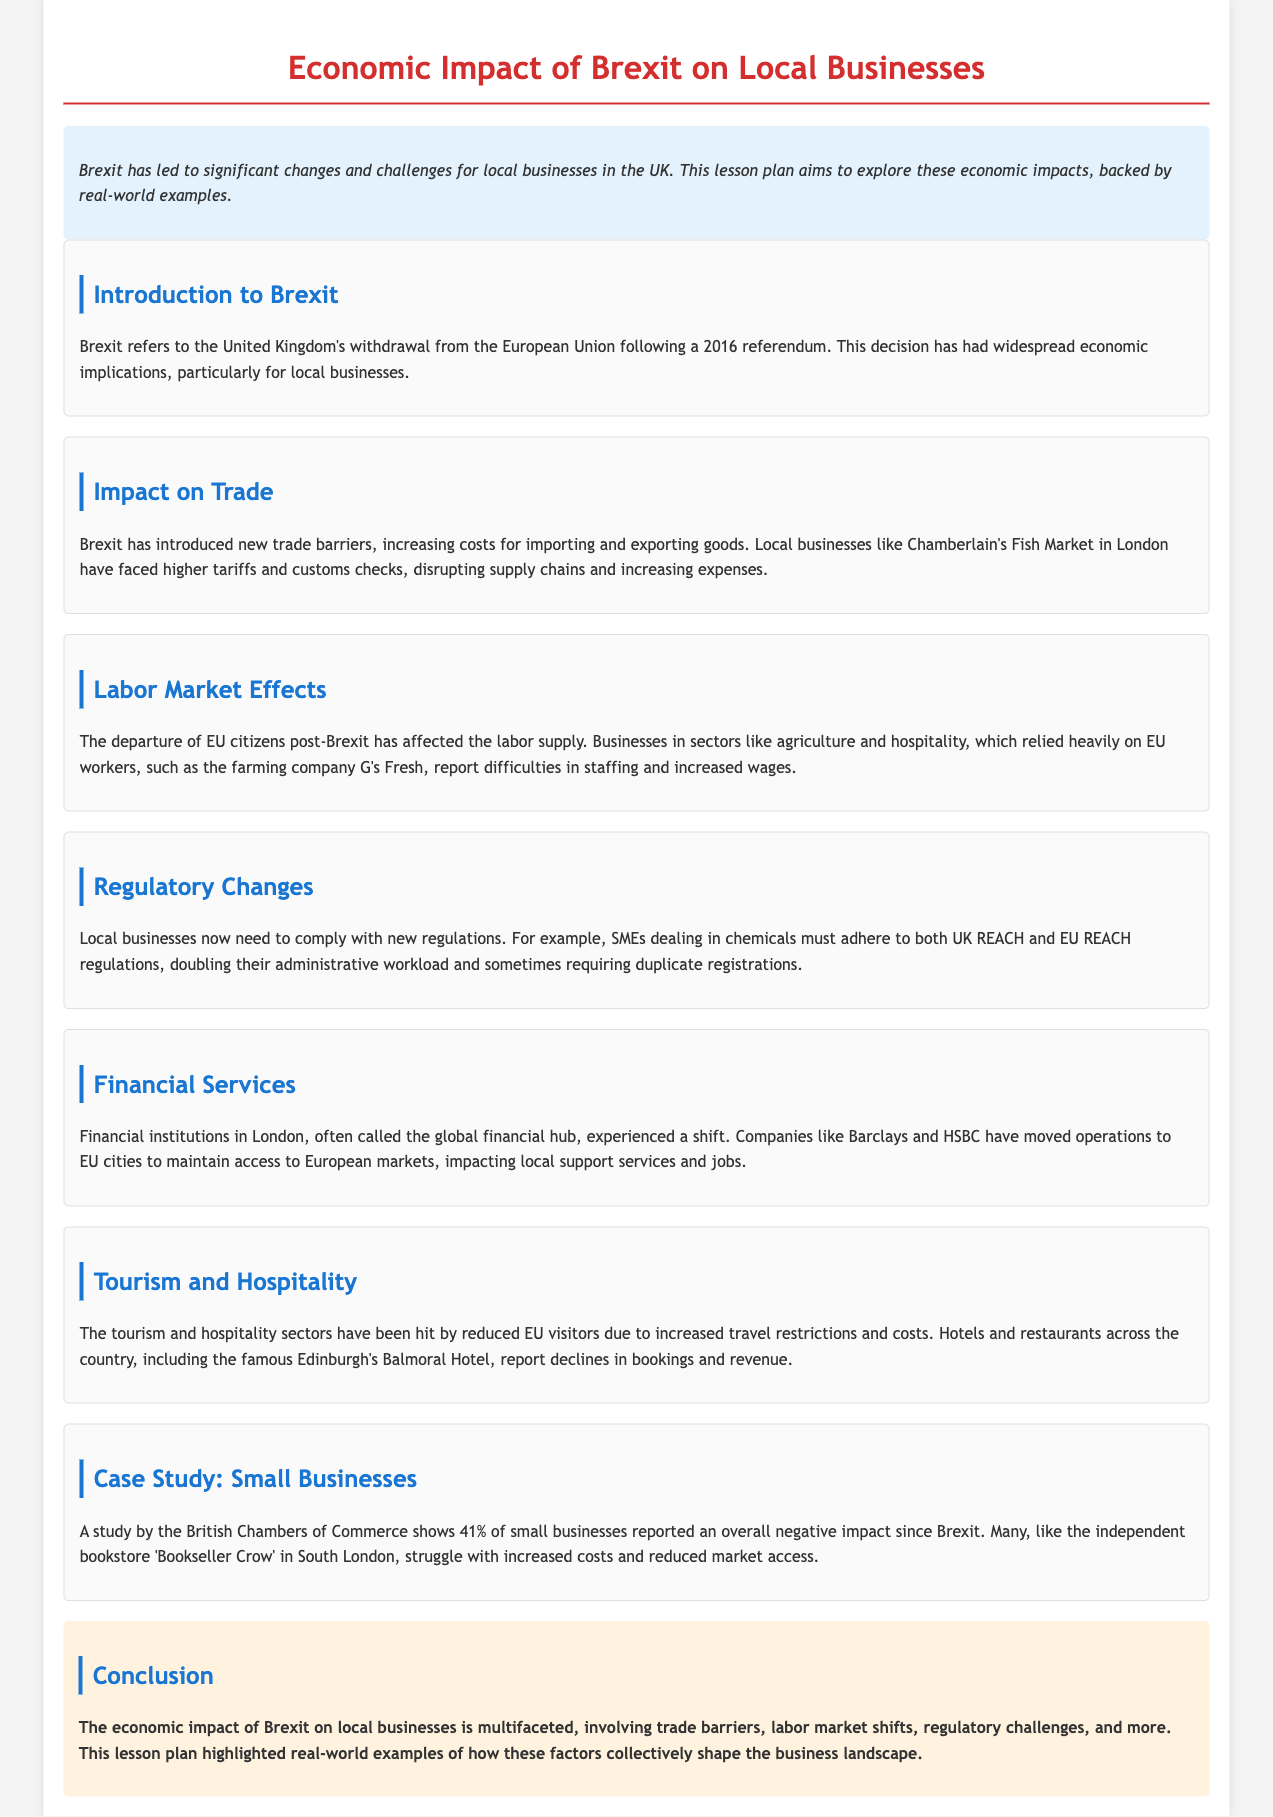What is Brexit? Brexit refers to the United Kingdom's withdrawal from the European Union following a 2016 referendum.
Answer: United Kingdom's withdrawal from the European Union What was the percentage of small businesses reporting a negative impact since Brexit? A study by the British Chambers of Commerce shows 41% of small businesses reported an overall negative impact since Brexit.
Answer: 41% Which sector has reported difficulties in staffing post-Brexit? Businesses in sectors like agriculture and hospitality, which relied heavily on EU workers, report difficulties in staffing.
Answer: Agriculture and hospitality What example is given for the financial services sector's response to Brexit? Companies like Barclays and HSBC have moved operations to EU cities to maintain access to European markets.
Answer: Barclays and HSBC What is the main topic of the lesson plan? The main topic is the economic impact of Brexit on local businesses.
Answer: Economic impact of Brexit on local businesses What specific challenge do SMEs dealing in chemicals face post-Brexit? SMEs must adhere to both UK REACH and EU REACH regulations, doubling their administrative workload.
Answer: New regulations How has the tourism sector been impacted by Brexit? The tourism and hospitality sectors have been hit by reduced EU visitors due to increased travel restrictions and costs.
Answer: Reduced EU visitors What type of businesses struggled with increased costs according to the document? Many, like the independent bookstore 'Bookseller Crow' in South London, struggle with increased costs and reduced market access.
Answer: Independent bookstore 'Bookseller Crow' What city is mentioned as experiencing declines in bookings and revenue in the hospitality sector? Edinburgh's Balmoral Hotel reports declines in bookings and revenue.
Answer: Edinburgh's Balmoral Hotel 